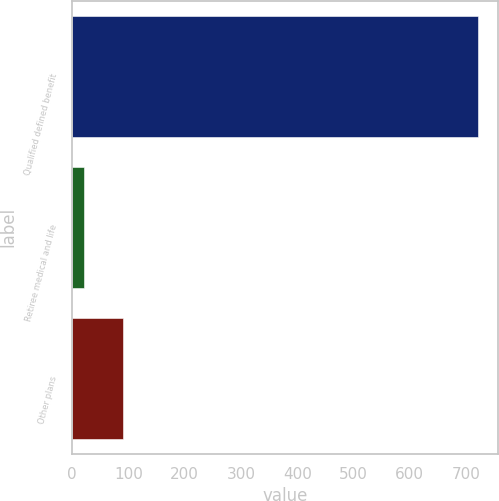Convert chart. <chart><loc_0><loc_0><loc_500><loc_500><bar_chart><fcel>Qualified defined benefit<fcel>Retiree medical and life<fcel>Other plans<nl><fcel>721<fcel>21<fcel>91<nl></chart> 